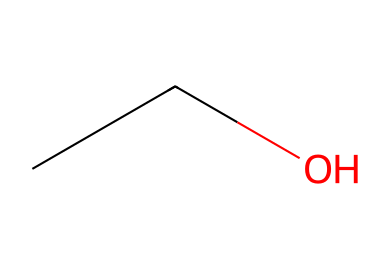What is the name of this chemical? The SMILES representation "CCO" corresponds to the molecular structure of ethanol, which is commonly found in alcoholic beverages.
Answer: ethanol How many carbon atoms are present in ethanol? The SMILES indicates two carbon atoms (CC) in the structure of ethanol.
Answer: 2 What functional group is present in ethanol? The end "O" in "CCO" indicates the presence of a hydroxyl group (-OH), which classifies ethanol as an alcohol.
Answer: hydroxyl group Is ethanol a flammable liquid? Ethanol has a low flash point, which makes it a flammable liquid, suitable for combustion and as a fuel.
Answer: yes What is the molecular formula for ethanol based on its structure? The structure contains two carbon atoms, six hydrogen atoms, and one oxygen atom, leading to the molecular formula C2H6O for ethanol.
Answer: C2H6O Why does ethanol mix well with water? The presence of the hydroxyl group (-OH) allows ethanol to form hydrogen bonds with water, leading to good solubility.
Answer: hydrogen bonding What is the primary use of ethanol seen at football matches? Ethanol is primarily used in beverages, such as alcoholic drinks, which are commonly consumed at social events like football matches.
Answer: beverages 